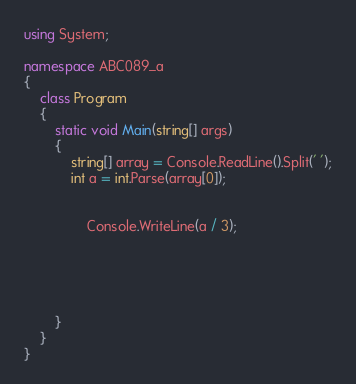<code> <loc_0><loc_0><loc_500><loc_500><_C#_>using System;

namespace ABC089_a
{
    class Program
    {
        static void Main(string[] args)
        {
            string[] array = Console.ReadLine().Split(' ');
            int a = int.Parse(array[0]);
            
            
                Console.WriteLine(a / 3);
            

                 
            
          
        }
    }
}
</code> 